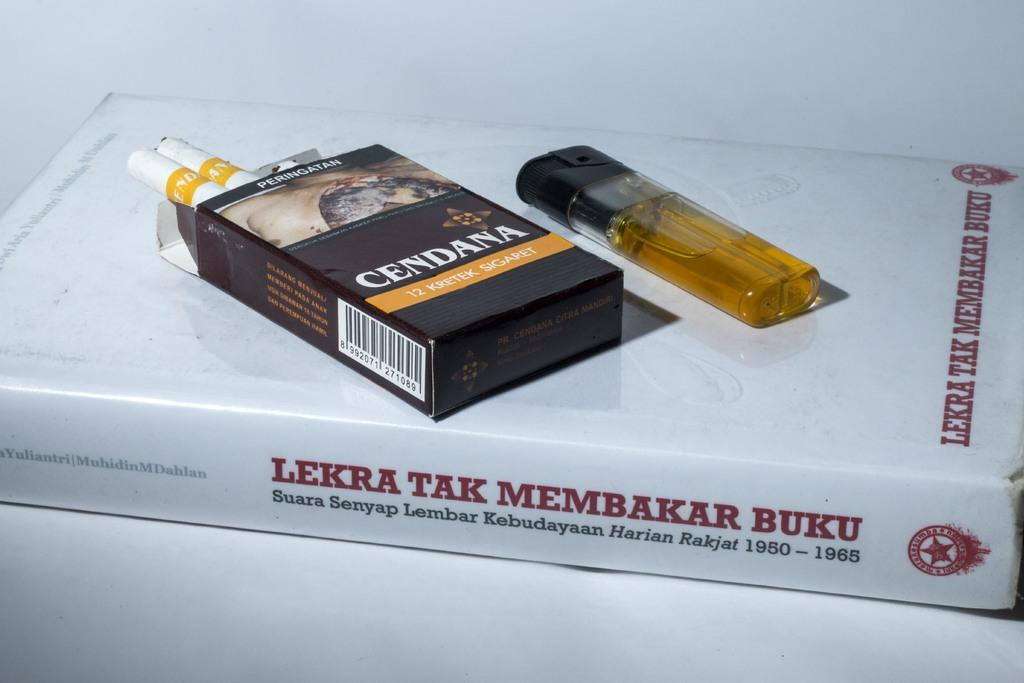<image>
Give a short and clear explanation of the subsequent image. a book underneath a carton of cigarettes and a yellow lighter that is titled 'lekra tak membakar buku' 